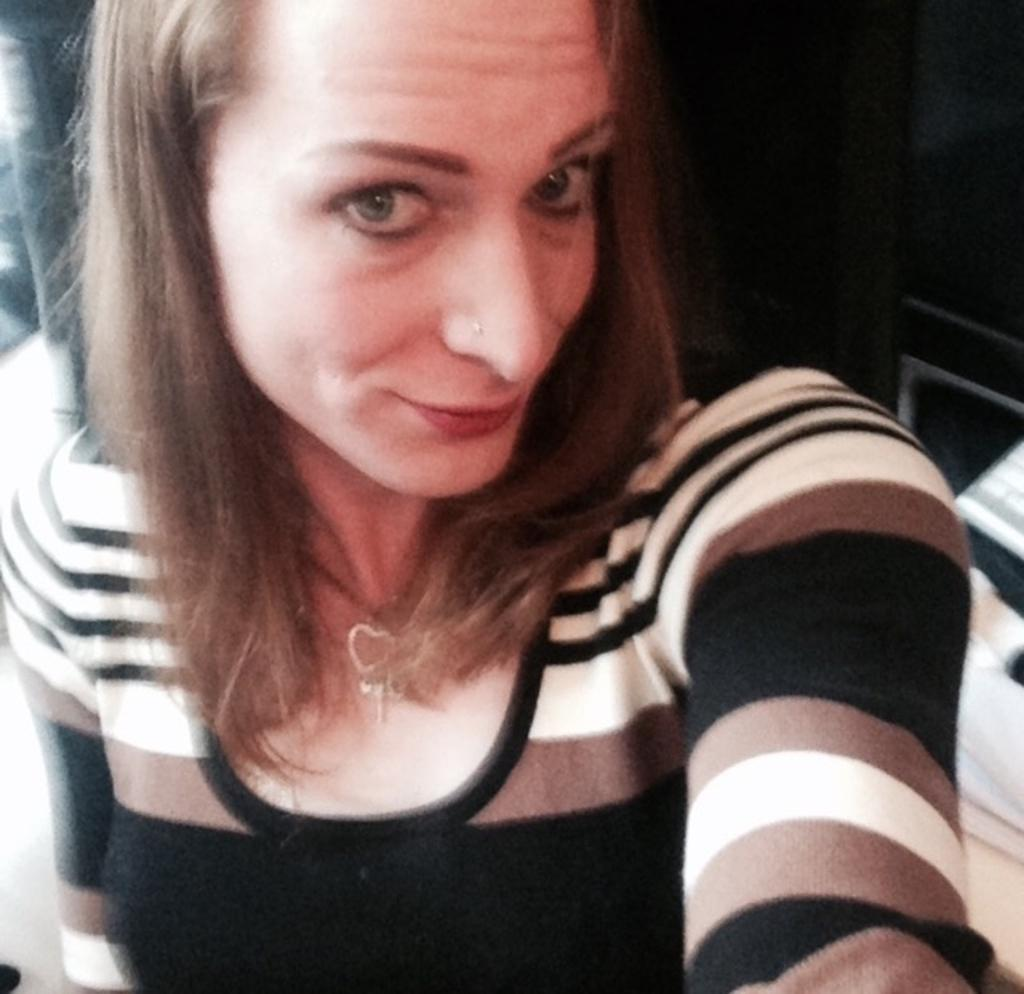Who is the main subject in the image? There is a woman in the image. What is the woman doing in the image? The woman is taking a selfie. Can you describe the background of the image? The background of the image is blurry. What type of flower can be seen in the garden in the image? There is no garden or flower present in the image; it features a woman taking a selfie with a blurry background. 